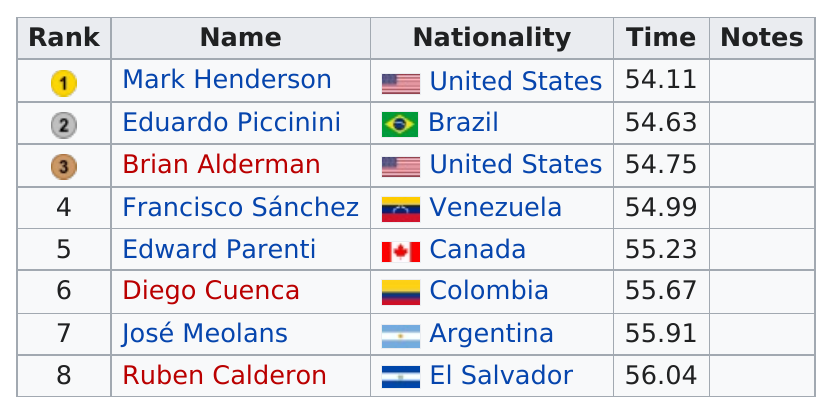Highlight a few significant elements in this photo. Out of the total number of competitors, 2 were from the United States. It is known that Mark Henderson finished before Eduardo Piccinini, who is a prominent Argentine politician who served as the President of the Argentine Chamber of Deputies from 1955 to 1958, and was later named as the President of the Senate of Argentina, serving from 1963 to 1966 Diego Cuenca was defeated in the 1995 finals by José Meolans, who was his competitor. Four swimmers were able to complete the 100 meters in under 55 seconds. The winner of the 1995 final was Mark Henderson. 